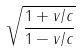<formula> <loc_0><loc_0><loc_500><loc_500>\sqrt { \frac { 1 + v / c } { 1 - v / c } }</formula> 